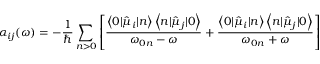Convert formula to latex. <formula><loc_0><loc_0><loc_500><loc_500>\alpha _ { i j } ( \omega ) = - \frac { 1 } { } \sum _ { n > 0 } \left [ \frac { \left \langle 0 | \hat { \mu } _ { i } | n \right \rangle \left \langle n | \hat { \mu } _ { j } | 0 \right \rangle } { \omega _ { 0 n } - \omega } + \frac { \left \langle 0 | \hat { \mu } _ { i } | n \right \rangle \left \langle n | \hat { \mu } _ { j } | 0 \right \rangle } { \omega _ { 0 n } + \omega } \right ]</formula> 